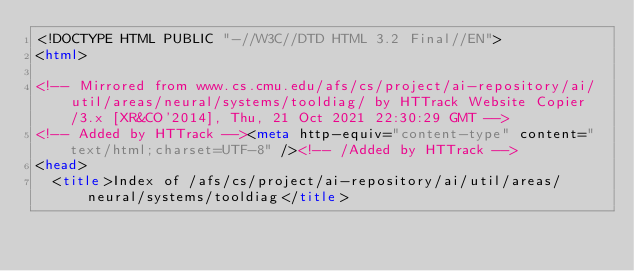Convert code to text. <code><loc_0><loc_0><loc_500><loc_500><_HTML_><!DOCTYPE HTML PUBLIC "-//W3C//DTD HTML 3.2 Final//EN">
<html>
 
<!-- Mirrored from www.cs.cmu.edu/afs/cs/project/ai-repository/ai/util/areas/neural/systems/tooldiag/ by HTTrack Website Copier/3.x [XR&CO'2014], Thu, 21 Oct 2021 22:30:29 GMT -->
<!-- Added by HTTrack --><meta http-equiv="content-type" content="text/html;charset=UTF-8" /><!-- /Added by HTTrack -->
<head>
  <title>Index of /afs/cs/project/ai-repository/ai/util/areas/neural/systems/tooldiag</title></code> 